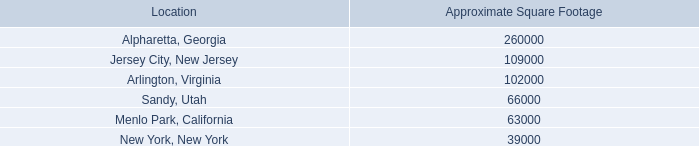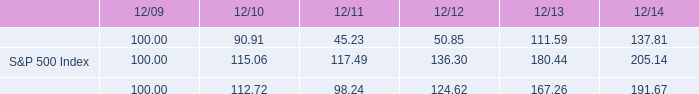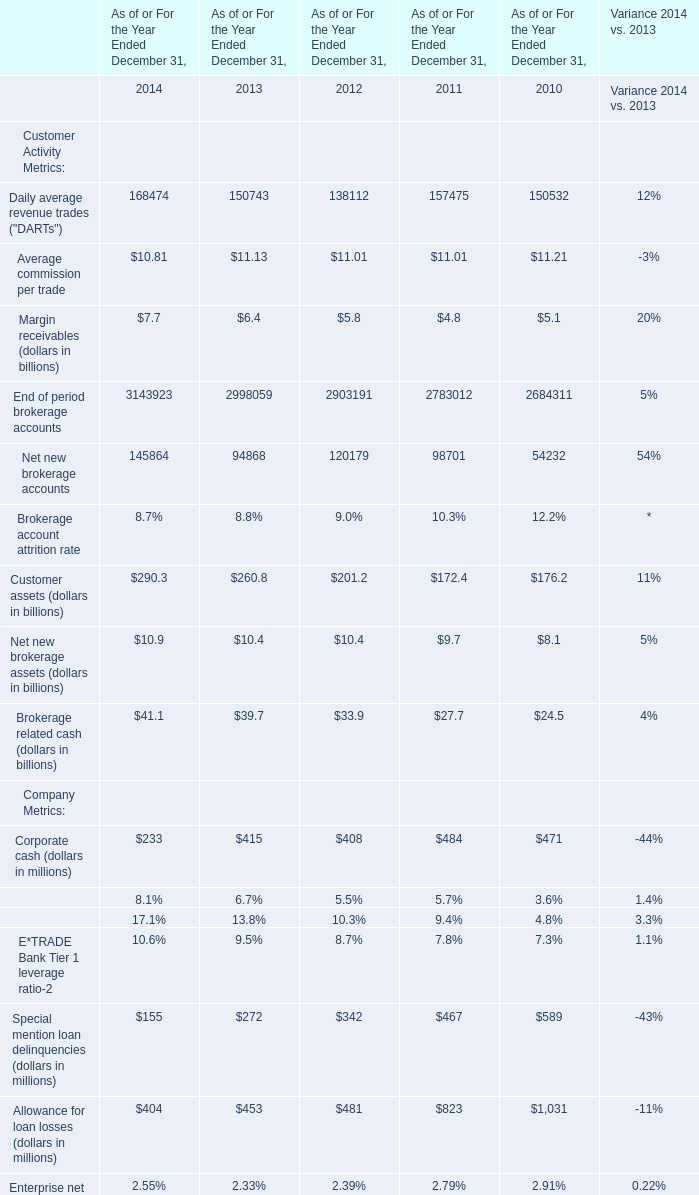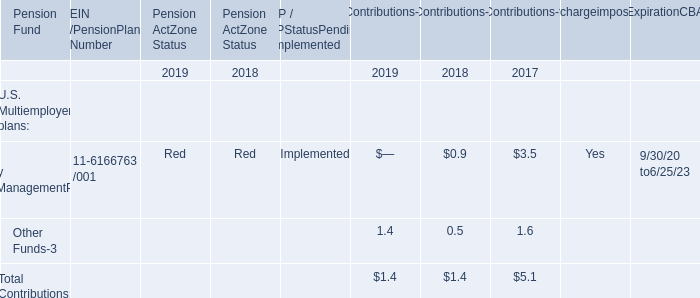Which year is Net new brokerage accounts the most? 
Answer: 2014. 